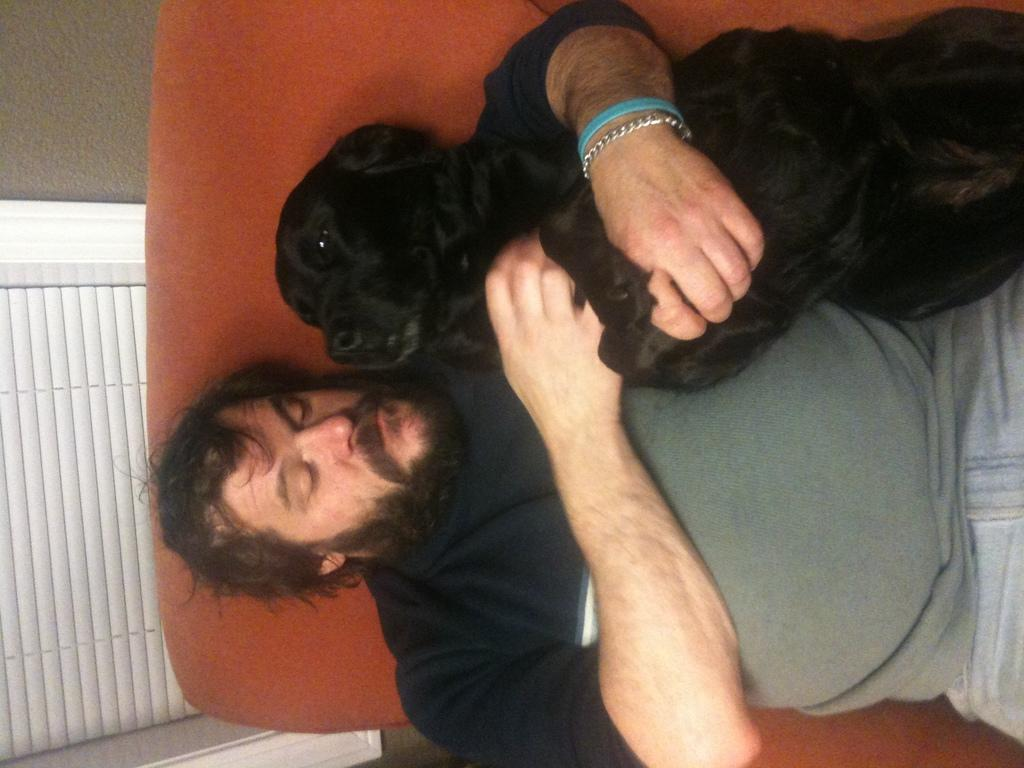What is the main subject of the image? There is a man in the image. What is the man doing in the image? The man is laying on a bed. What is the man holding in his hand? The man is holding a dog in his hand. What accessory is on the man's hand? The man has a bracelet on his hand. What is next to the bracelet on the man's hand? There is a band next to the bracelet. What can be seen in the background of the image? There is a wall and a window in the background of the image. What government policy is being discussed in the image? There is no discussion of government policy in the image. 